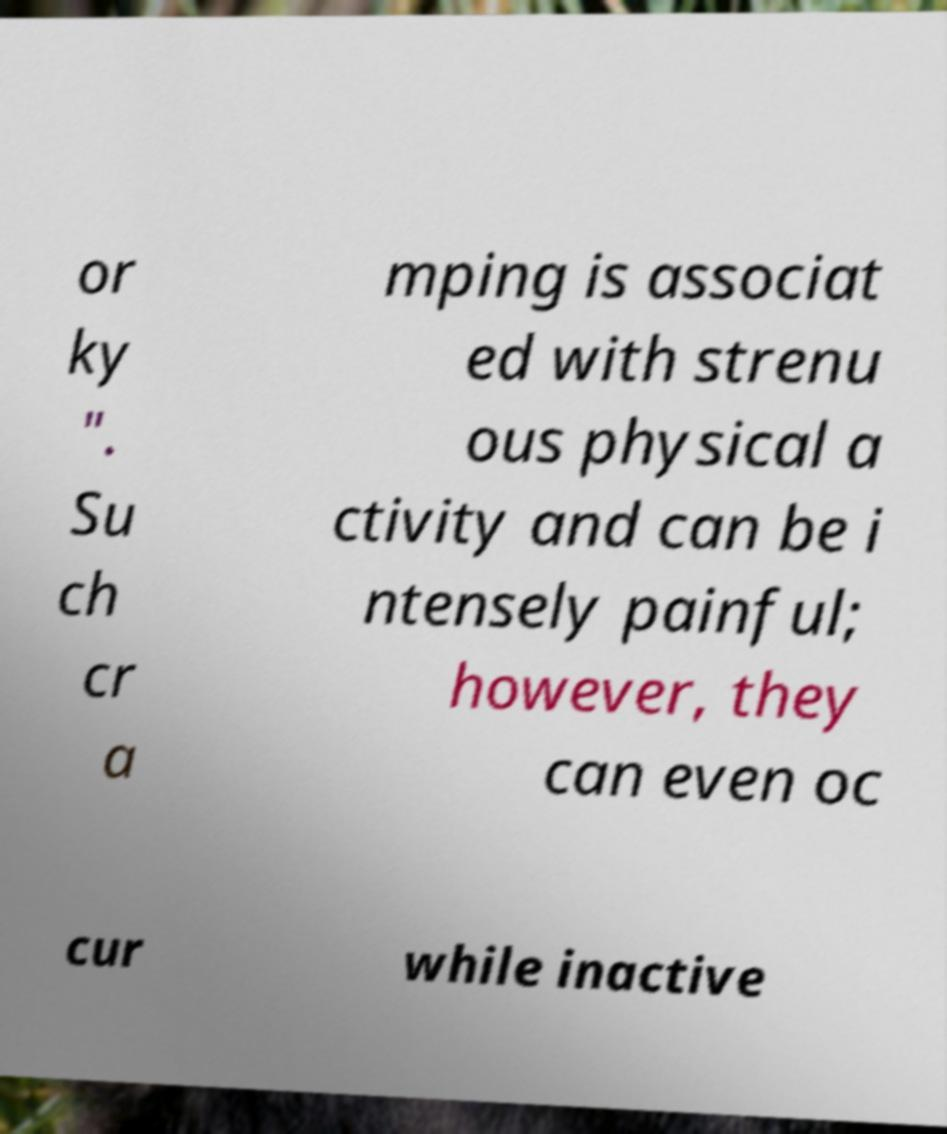Can you accurately transcribe the text from the provided image for me? or ky ". Su ch cr a mping is associat ed with strenu ous physical a ctivity and can be i ntensely painful; however, they can even oc cur while inactive 